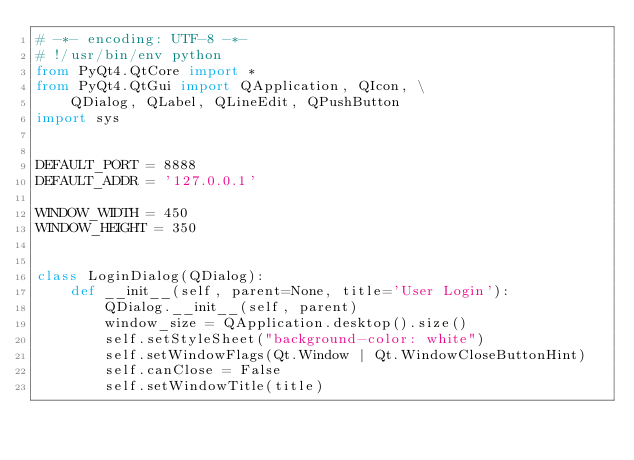<code> <loc_0><loc_0><loc_500><loc_500><_Python_># -*- encoding: UTF-8 -*-
# !/usr/bin/env python
from PyQt4.QtCore import *
from PyQt4.QtGui import QApplication, QIcon, \
    QDialog, QLabel, QLineEdit, QPushButton
import sys


DEFAULT_PORT = 8888
DEFAULT_ADDR = '127.0.0.1'

WINDOW_WIDTH = 450
WINDOW_HEIGHT = 350


class LoginDialog(QDialog):
    def __init__(self, parent=None, title='User Login'):
        QDialog.__init__(self, parent)
        window_size = QApplication.desktop().size()
        self.setStyleSheet("background-color: white")
        self.setWindowFlags(Qt.Window | Qt.WindowCloseButtonHint)
        self.canClose = False
        self.setWindowTitle(title)</code> 